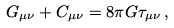Convert formula to latex. <formula><loc_0><loc_0><loc_500><loc_500>G _ { \mu \nu } + C _ { \mu \nu } = 8 \pi G \tau _ { \mu \nu } \, ,</formula> 